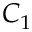Convert formula to latex. <formula><loc_0><loc_0><loc_500><loc_500>C _ { 1 }</formula> 